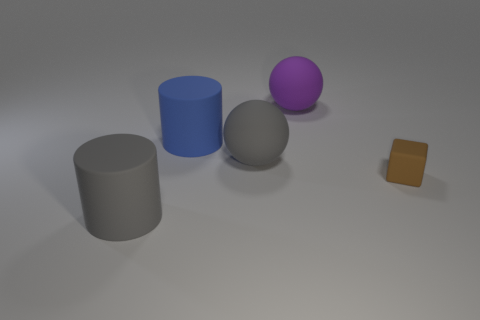Are there any other things that are the same size as the brown matte cube?
Your response must be concise. No. Does the sphere behind the large blue cylinder have the same size as the object that is right of the large purple sphere?
Your answer should be very brief. No. How big is the ball that is in front of the big sphere that is behind the big matte cylinder behind the large gray matte sphere?
Keep it short and to the point. Large. Are there more big cylinders that are behind the brown block than green metallic cylinders?
Your response must be concise. Yes. What size is the matte thing that is in front of the big blue matte cylinder and behind the rubber cube?
Keep it short and to the point. Large. There is a object that is both on the right side of the big gray ball and to the left of the small object; what shape is it?
Give a very brief answer. Sphere. Is there a matte sphere behind the large matte cylinder that is behind the thing that is right of the big purple ball?
Offer a very short reply. Yes. How many things are either big rubber spheres that are to the left of the purple object or big rubber cylinders behind the brown matte thing?
Make the answer very short. 2. Are the cylinder that is in front of the brown cube and the blue object made of the same material?
Your response must be concise. Yes. What color is the big rubber cylinder that is behind the big gray object that is behind the tiny object?
Provide a succinct answer. Blue. 